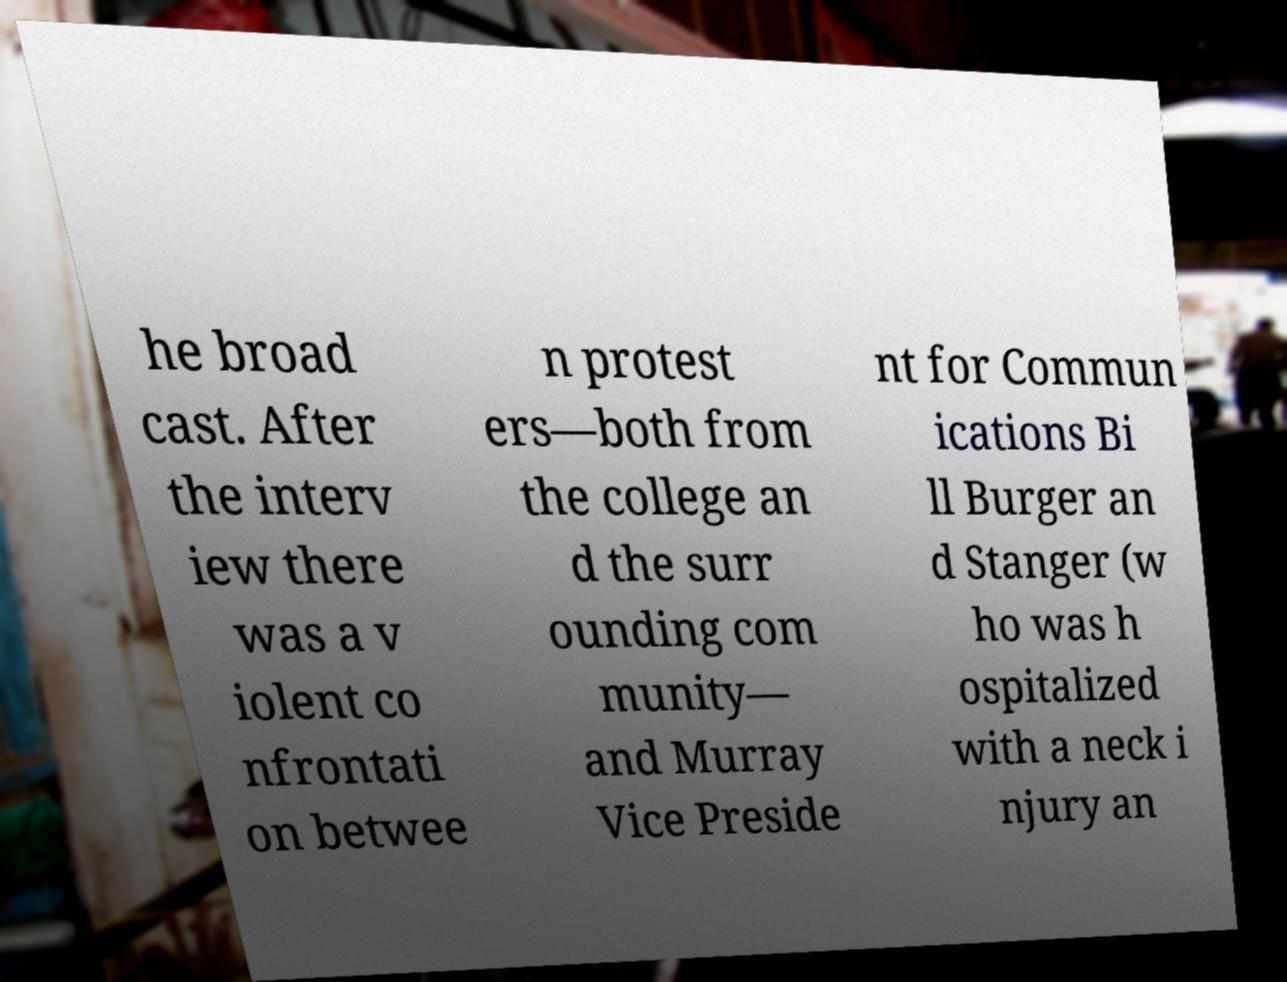Could you assist in decoding the text presented in this image and type it out clearly? he broad cast. After the interv iew there was a v iolent co nfrontati on betwee n protest ers—both from the college an d the surr ounding com munity— and Murray Vice Preside nt for Commun ications Bi ll Burger an d Stanger (w ho was h ospitalized with a neck i njury an 